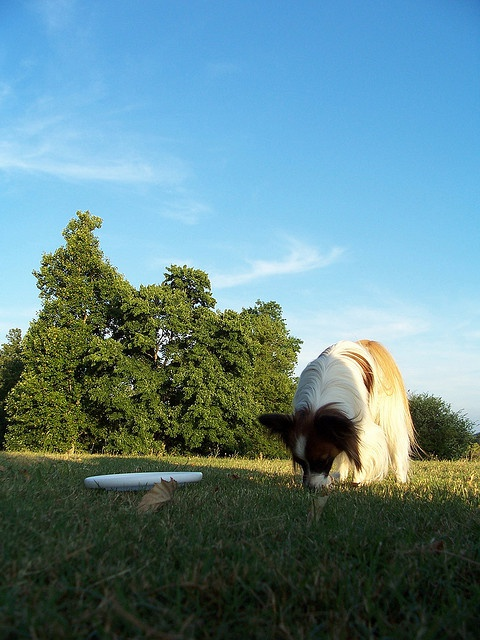Describe the objects in this image and their specific colors. I can see dog in gray, black, lightyellow, khaki, and darkgray tones and frisbee in gray, lightblue, and darkgray tones in this image. 